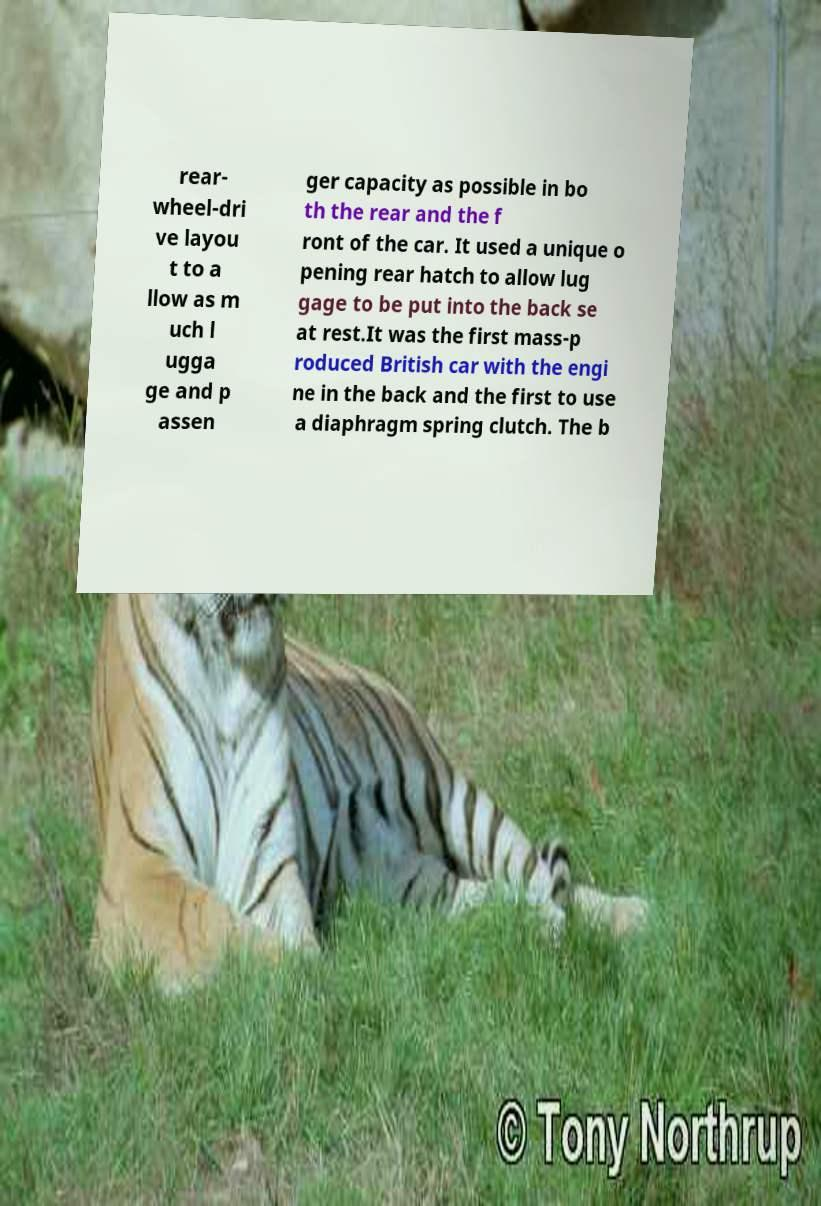Can you read and provide the text displayed in the image?This photo seems to have some interesting text. Can you extract and type it out for me? rear- wheel-dri ve layou t to a llow as m uch l ugga ge and p assen ger capacity as possible in bo th the rear and the f ront of the car. It used a unique o pening rear hatch to allow lug gage to be put into the back se at rest.It was the first mass-p roduced British car with the engi ne in the back and the first to use a diaphragm spring clutch. The b 